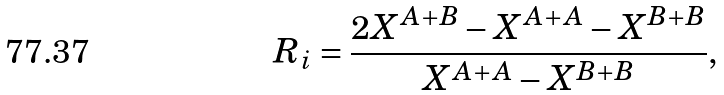<formula> <loc_0><loc_0><loc_500><loc_500>R _ { i } = \frac { 2 X ^ { A + B } - X ^ { A + A } - X ^ { B + B } } { X ^ { A + A } - X ^ { B + B } } ,</formula> 